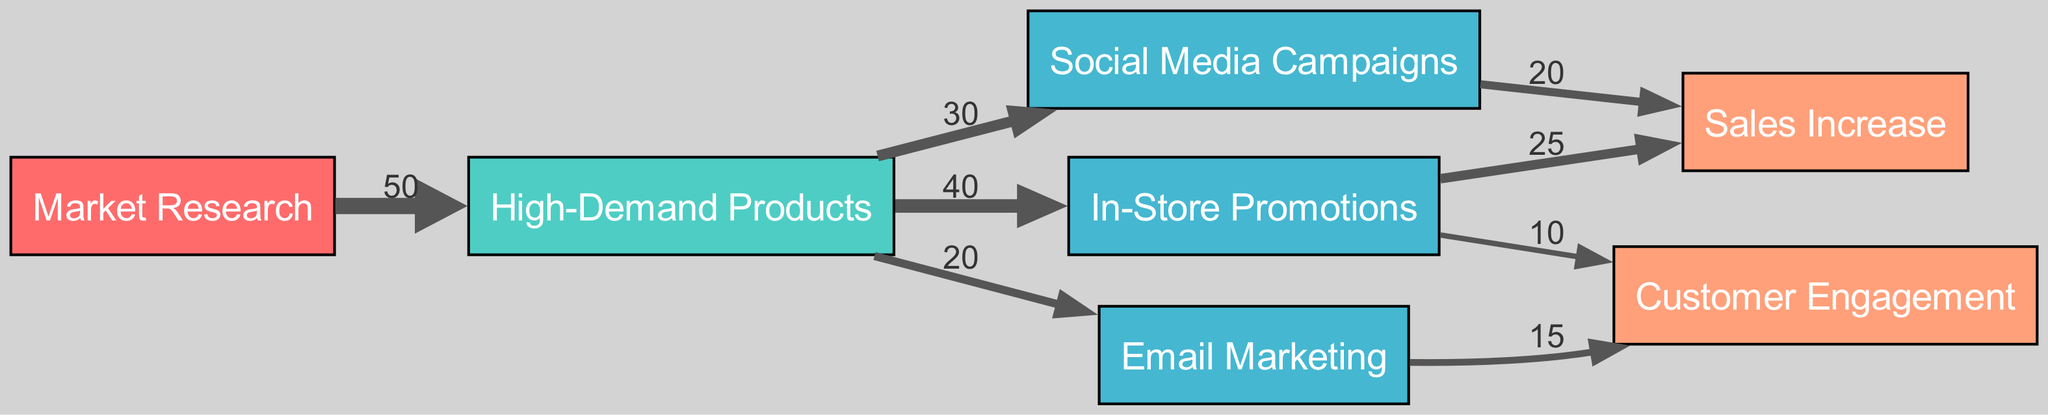What is the total number of nodes in the diagram? There are 7 nodes: Market Research, High-Demand Products, Social Media Campaigns, Email Marketing, In-Store Promotions, Sales Increase, and Customer Engagement. Counting each unique node gives us a total of 7.
Answer: 7 What is the total value of connections from High-Demand Products to marketing campaigns? The total value of connections from High-Demand Products is calculated by adding the values of its outgoing connections: 30 (Social Media Campaigns) + 20 (Email Marketing) + 40 (In-Store Promotions) = 90.
Answer: 90 Which marketing campaign has the highest value allocated to it? By examining the links from High-Demand Products, In-Store Promotions has the highest value allocated, with a value of 40.
Answer: In-Store Promotions What percentage of the allocated funds towards High-Demand Products leads to Sales Increase? From High-Demand Products, there are two outgoing links to Sales Increase: one from In-Store Promotions (25) and one from Social Media Campaigns (20). The total allocation towards High-Demand Products is 90, so the total for Sales Increase is 25 + 20 = 45. The percentage is calculated as (45 / 90) * 100 = 50%.
Answer: 50% Which outcome receives contributions from both marketing campaigns and how much in total? Customer Engagement receives contributions from Email Marketing (15) and In-Store Promotions (10). The total amount is 15 + 10 = 25.
Answer: 25 What is the total value of outcomes linked to In-Store Promotions? In-Store Promotions connects to two outcomes: Sales Increase (25) and Customer Engagement (10). By adding these, we find that the total value of outcomes linked to In-Store Promotions is 25 + 10 = 35.
Answer: 35 How many edges lead from High-Demand Products to marketing campaigns? There are three edges leading from High-Demand Products: to Social Media Campaigns, Email Marketing, and In-Store Promotions, totaling 3 edges.
Answer: 3 What is the value of the connection from Social Media Campaigns to Sales Increase? The connection from Social Media Campaigns to Sales Increase has a value of 20, which can be directly read from the outgoing link in the diagram.
Answer: 20 